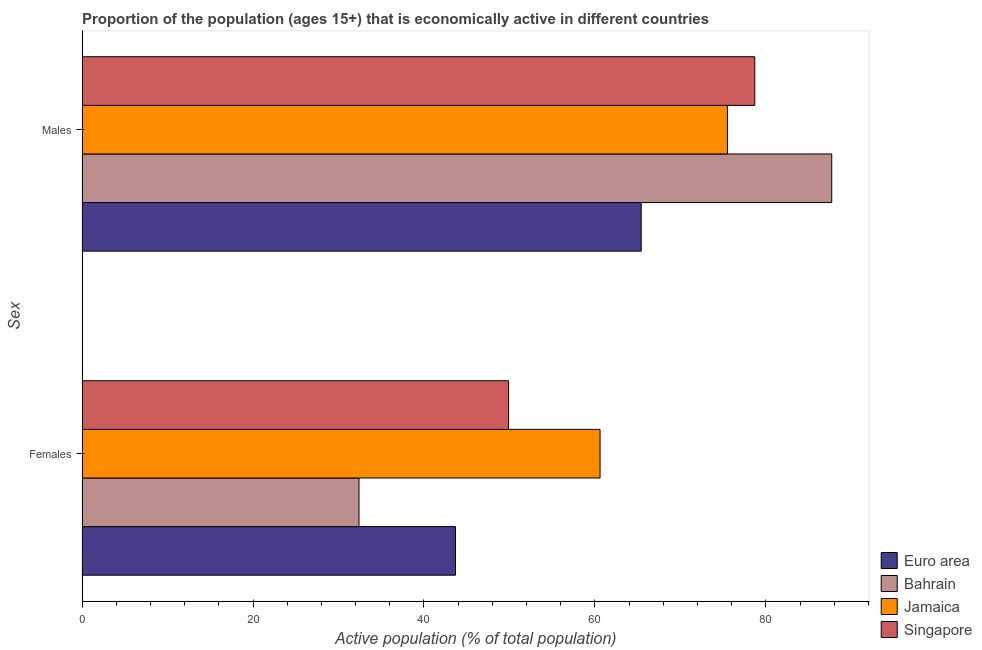How many different coloured bars are there?
Keep it short and to the point. 4. How many groups of bars are there?
Offer a very short reply. 2. Are the number of bars per tick equal to the number of legend labels?
Provide a succinct answer. Yes. Are the number of bars on each tick of the Y-axis equal?
Offer a very short reply. Yes. How many bars are there on the 1st tick from the bottom?
Your answer should be very brief. 4. What is the label of the 2nd group of bars from the top?
Your response must be concise. Females. What is the percentage of economically active male population in Euro area?
Offer a terse response. 65.41. Across all countries, what is the maximum percentage of economically active female population?
Offer a terse response. 60.6. Across all countries, what is the minimum percentage of economically active male population?
Provide a short and direct response. 65.41. In which country was the percentage of economically active male population maximum?
Your response must be concise. Bahrain. What is the total percentage of economically active male population in the graph?
Offer a very short reply. 307.31. What is the difference between the percentage of economically active male population in Jamaica and the percentage of economically active female population in Singapore?
Provide a short and direct response. 25.6. What is the average percentage of economically active female population per country?
Offer a terse response. 46.65. What is the difference between the percentage of economically active male population and percentage of economically active female population in Singapore?
Offer a terse response. 28.8. What is the ratio of the percentage of economically active male population in Jamaica to that in Euro area?
Offer a terse response. 1.15. Is the percentage of economically active male population in Singapore less than that in Jamaica?
Ensure brevity in your answer.  No. In how many countries, is the percentage of economically active male population greater than the average percentage of economically active male population taken over all countries?
Offer a very short reply. 2. What does the 2nd bar from the top in Males represents?
Offer a terse response. Jamaica. What does the 1st bar from the bottom in Males represents?
Your answer should be very brief. Euro area. How many bars are there?
Keep it short and to the point. 8. Are all the bars in the graph horizontal?
Ensure brevity in your answer.  Yes. How many countries are there in the graph?
Ensure brevity in your answer.  4. What is the difference between two consecutive major ticks on the X-axis?
Your answer should be very brief. 20. Are the values on the major ticks of X-axis written in scientific E-notation?
Ensure brevity in your answer.  No. Does the graph contain any zero values?
Give a very brief answer. No. How many legend labels are there?
Make the answer very short. 4. What is the title of the graph?
Offer a very short reply. Proportion of the population (ages 15+) that is economically active in different countries. What is the label or title of the X-axis?
Ensure brevity in your answer.  Active population (% of total population). What is the label or title of the Y-axis?
Give a very brief answer. Sex. What is the Active population (% of total population) in Euro area in Females?
Your response must be concise. 43.69. What is the Active population (% of total population) of Bahrain in Females?
Offer a very short reply. 32.4. What is the Active population (% of total population) in Jamaica in Females?
Offer a very short reply. 60.6. What is the Active population (% of total population) in Singapore in Females?
Offer a terse response. 49.9. What is the Active population (% of total population) in Euro area in Males?
Ensure brevity in your answer.  65.41. What is the Active population (% of total population) of Bahrain in Males?
Provide a succinct answer. 87.7. What is the Active population (% of total population) in Jamaica in Males?
Your response must be concise. 75.5. What is the Active population (% of total population) in Singapore in Males?
Your answer should be very brief. 78.7. Across all Sex, what is the maximum Active population (% of total population) of Euro area?
Provide a short and direct response. 65.41. Across all Sex, what is the maximum Active population (% of total population) of Bahrain?
Your answer should be very brief. 87.7. Across all Sex, what is the maximum Active population (% of total population) in Jamaica?
Your response must be concise. 75.5. Across all Sex, what is the maximum Active population (% of total population) of Singapore?
Your answer should be compact. 78.7. Across all Sex, what is the minimum Active population (% of total population) of Euro area?
Provide a short and direct response. 43.69. Across all Sex, what is the minimum Active population (% of total population) in Bahrain?
Ensure brevity in your answer.  32.4. Across all Sex, what is the minimum Active population (% of total population) of Jamaica?
Keep it short and to the point. 60.6. Across all Sex, what is the minimum Active population (% of total population) of Singapore?
Offer a very short reply. 49.9. What is the total Active population (% of total population) in Euro area in the graph?
Keep it short and to the point. 109.1. What is the total Active population (% of total population) of Bahrain in the graph?
Your answer should be very brief. 120.1. What is the total Active population (% of total population) of Jamaica in the graph?
Your answer should be very brief. 136.1. What is the total Active population (% of total population) of Singapore in the graph?
Offer a terse response. 128.6. What is the difference between the Active population (% of total population) of Euro area in Females and that in Males?
Offer a very short reply. -21.73. What is the difference between the Active population (% of total population) of Bahrain in Females and that in Males?
Provide a short and direct response. -55.3. What is the difference between the Active population (% of total population) in Jamaica in Females and that in Males?
Keep it short and to the point. -14.9. What is the difference between the Active population (% of total population) of Singapore in Females and that in Males?
Give a very brief answer. -28.8. What is the difference between the Active population (% of total population) of Euro area in Females and the Active population (% of total population) of Bahrain in Males?
Keep it short and to the point. -44.01. What is the difference between the Active population (% of total population) of Euro area in Females and the Active population (% of total population) of Jamaica in Males?
Offer a terse response. -31.81. What is the difference between the Active population (% of total population) of Euro area in Females and the Active population (% of total population) of Singapore in Males?
Your answer should be compact. -35.01. What is the difference between the Active population (% of total population) in Bahrain in Females and the Active population (% of total population) in Jamaica in Males?
Offer a terse response. -43.1. What is the difference between the Active population (% of total population) in Bahrain in Females and the Active population (% of total population) in Singapore in Males?
Provide a succinct answer. -46.3. What is the difference between the Active population (% of total population) in Jamaica in Females and the Active population (% of total population) in Singapore in Males?
Your answer should be compact. -18.1. What is the average Active population (% of total population) of Euro area per Sex?
Offer a terse response. 54.55. What is the average Active population (% of total population) of Bahrain per Sex?
Offer a terse response. 60.05. What is the average Active population (% of total population) in Jamaica per Sex?
Your answer should be very brief. 68.05. What is the average Active population (% of total population) in Singapore per Sex?
Your response must be concise. 64.3. What is the difference between the Active population (% of total population) of Euro area and Active population (% of total population) of Bahrain in Females?
Offer a very short reply. 11.29. What is the difference between the Active population (% of total population) of Euro area and Active population (% of total population) of Jamaica in Females?
Provide a succinct answer. -16.91. What is the difference between the Active population (% of total population) in Euro area and Active population (% of total population) in Singapore in Females?
Give a very brief answer. -6.21. What is the difference between the Active population (% of total population) of Bahrain and Active population (% of total population) of Jamaica in Females?
Provide a succinct answer. -28.2. What is the difference between the Active population (% of total population) of Bahrain and Active population (% of total population) of Singapore in Females?
Make the answer very short. -17.5. What is the difference between the Active population (% of total population) of Jamaica and Active population (% of total population) of Singapore in Females?
Ensure brevity in your answer.  10.7. What is the difference between the Active population (% of total population) in Euro area and Active population (% of total population) in Bahrain in Males?
Your response must be concise. -22.29. What is the difference between the Active population (% of total population) of Euro area and Active population (% of total population) of Jamaica in Males?
Your answer should be very brief. -10.09. What is the difference between the Active population (% of total population) in Euro area and Active population (% of total population) in Singapore in Males?
Offer a terse response. -13.29. What is the difference between the Active population (% of total population) in Bahrain and Active population (% of total population) in Jamaica in Males?
Provide a short and direct response. 12.2. What is the difference between the Active population (% of total population) in Jamaica and Active population (% of total population) in Singapore in Males?
Your response must be concise. -3.2. What is the ratio of the Active population (% of total population) in Euro area in Females to that in Males?
Make the answer very short. 0.67. What is the ratio of the Active population (% of total population) in Bahrain in Females to that in Males?
Offer a terse response. 0.37. What is the ratio of the Active population (% of total population) in Jamaica in Females to that in Males?
Give a very brief answer. 0.8. What is the ratio of the Active population (% of total population) in Singapore in Females to that in Males?
Offer a terse response. 0.63. What is the difference between the highest and the second highest Active population (% of total population) in Euro area?
Offer a very short reply. 21.73. What is the difference between the highest and the second highest Active population (% of total population) of Bahrain?
Your response must be concise. 55.3. What is the difference between the highest and the second highest Active population (% of total population) of Jamaica?
Your response must be concise. 14.9. What is the difference between the highest and the second highest Active population (% of total population) of Singapore?
Offer a very short reply. 28.8. What is the difference between the highest and the lowest Active population (% of total population) of Euro area?
Provide a short and direct response. 21.73. What is the difference between the highest and the lowest Active population (% of total population) of Bahrain?
Offer a terse response. 55.3. What is the difference between the highest and the lowest Active population (% of total population) in Jamaica?
Offer a terse response. 14.9. What is the difference between the highest and the lowest Active population (% of total population) in Singapore?
Make the answer very short. 28.8. 